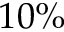<formula> <loc_0><loc_0><loc_500><loc_500>1 0 \%</formula> 